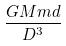Convert formula to latex. <formula><loc_0><loc_0><loc_500><loc_500>\frac { G M m d } { D ^ { 3 } }</formula> 